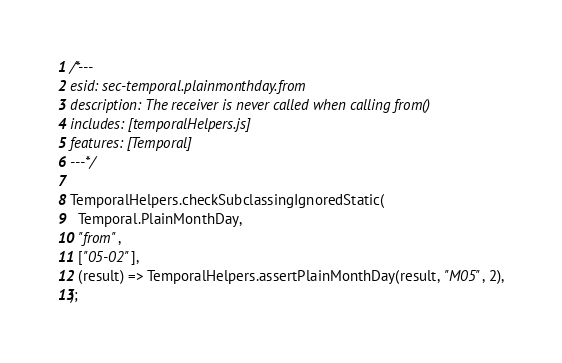<code> <loc_0><loc_0><loc_500><loc_500><_JavaScript_>
/*---
esid: sec-temporal.plainmonthday.from
description: The receiver is never called when calling from()
includes: [temporalHelpers.js]
features: [Temporal]
---*/

TemporalHelpers.checkSubclassingIgnoredStatic(
  Temporal.PlainMonthDay,
  "from",
  ["05-02"],
  (result) => TemporalHelpers.assertPlainMonthDay(result, "M05", 2),
);
</code> 